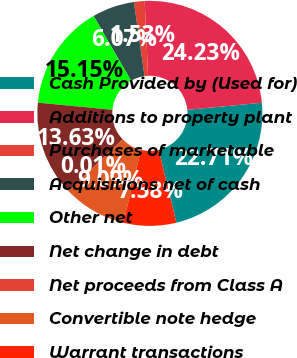Convert chart. <chart><loc_0><loc_0><loc_500><loc_500><pie_chart><fcel>Cash Provided by (Used for)<fcel>Additions to property plant<fcel>Purchases of marketable<fcel>Acquisitions net of cash<fcel>Other net<fcel>Net change in debt<fcel>Net proceeds from Class A<fcel>Convertible note hedge<fcel>Warrant transactions<nl><fcel>22.71%<fcel>24.23%<fcel>1.53%<fcel>6.07%<fcel>15.15%<fcel>13.63%<fcel>0.01%<fcel>9.09%<fcel>7.58%<nl></chart> 